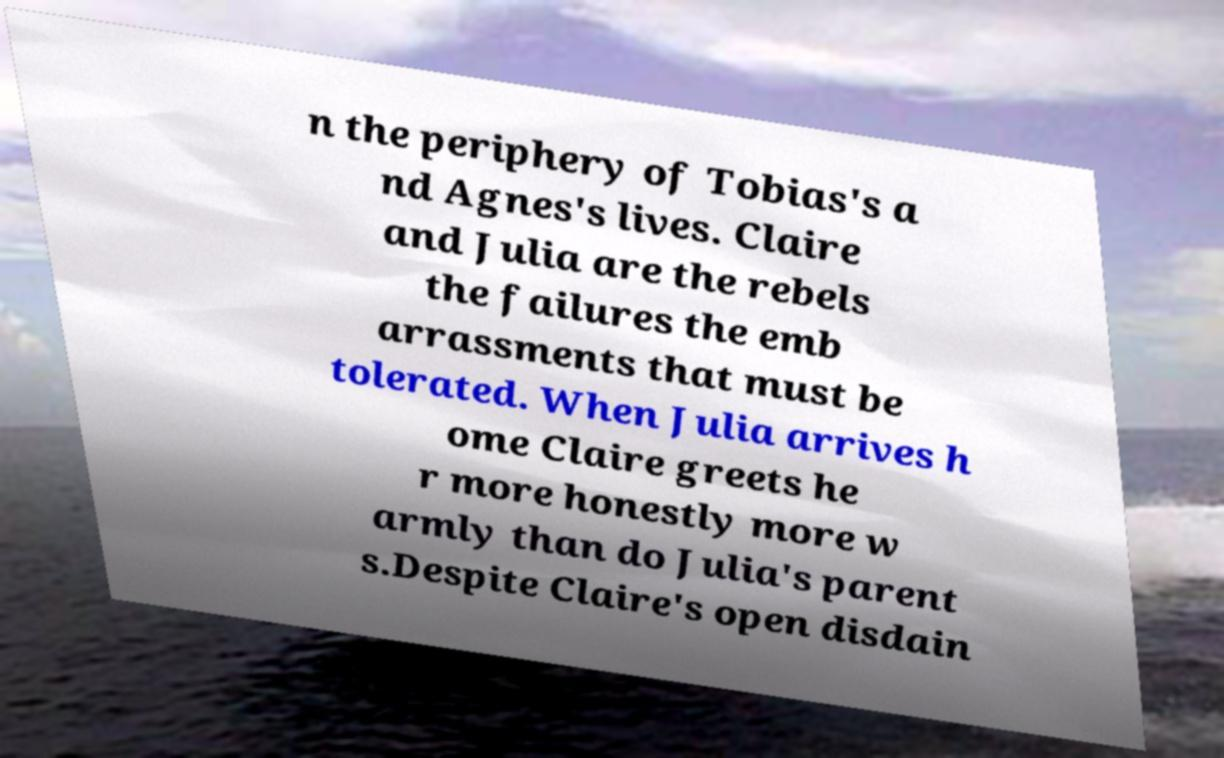What messages or text are displayed in this image? I need them in a readable, typed format. n the periphery of Tobias's a nd Agnes's lives. Claire and Julia are the rebels the failures the emb arrassments that must be tolerated. When Julia arrives h ome Claire greets he r more honestly more w armly than do Julia's parent s.Despite Claire's open disdain 